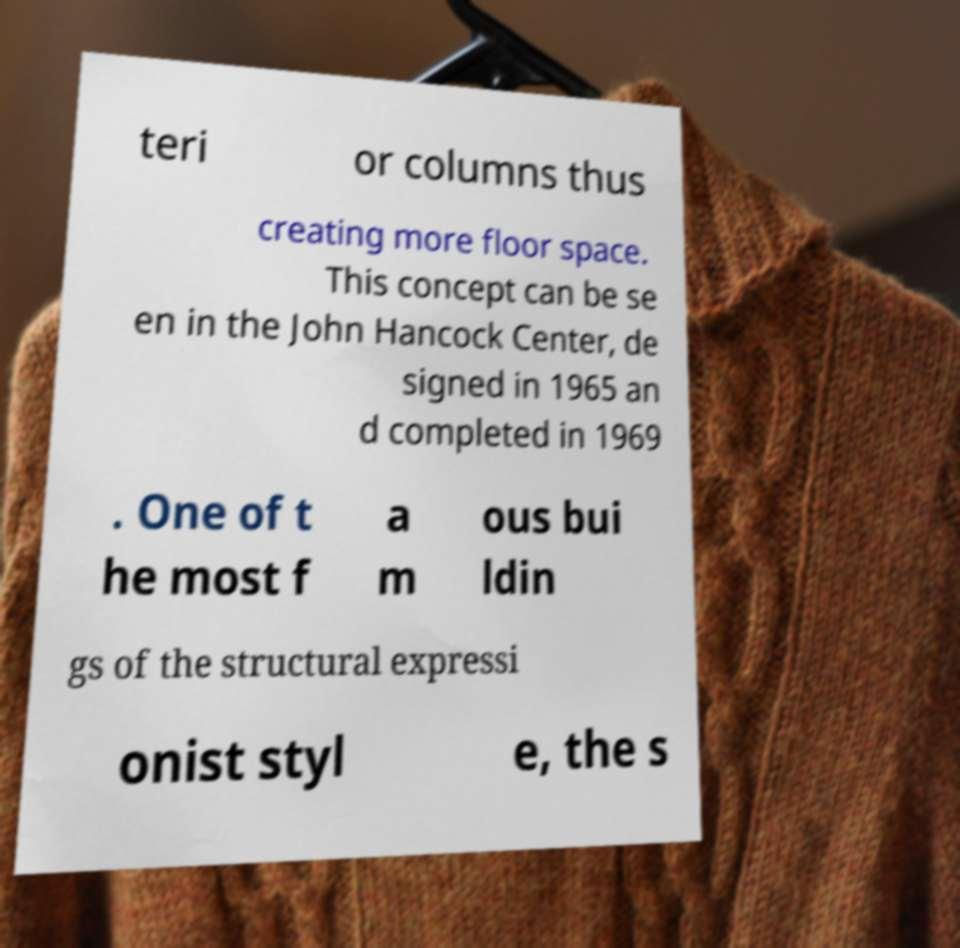Could you assist in decoding the text presented in this image and type it out clearly? teri or columns thus creating more floor space. This concept can be se en in the John Hancock Center, de signed in 1965 an d completed in 1969 . One of t he most f a m ous bui ldin gs of the structural expressi onist styl e, the s 